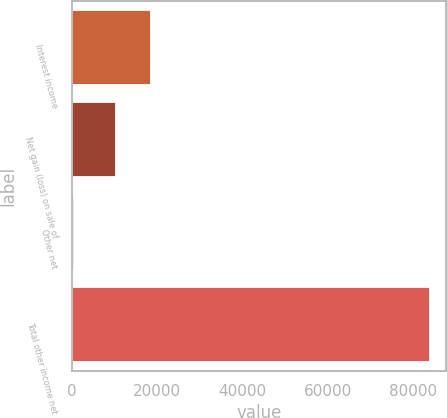<chart> <loc_0><loc_0><loc_500><loc_500><bar_chart><fcel>Interest income<fcel>Net gain (loss) on sale of<fcel>Other net<fcel>Total other income net<nl><fcel>18442.9<fcel>10131<fcel>401<fcel>83520<nl></chart> 